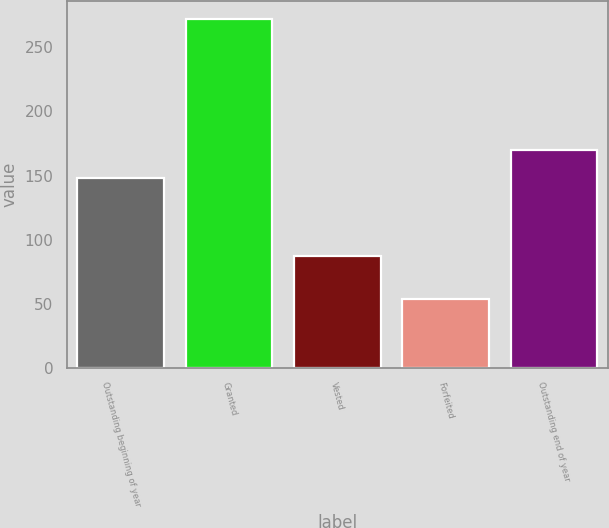<chart> <loc_0><loc_0><loc_500><loc_500><bar_chart><fcel>Outstanding beginning of year<fcel>Granted<fcel>Vested<fcel>Forfeited<fcel>Outstanding end of year<nl><fcel>148.22<fcel>272.28<fcel>87.36<fcel>53.36<fcel>170.11<nl></chart> 